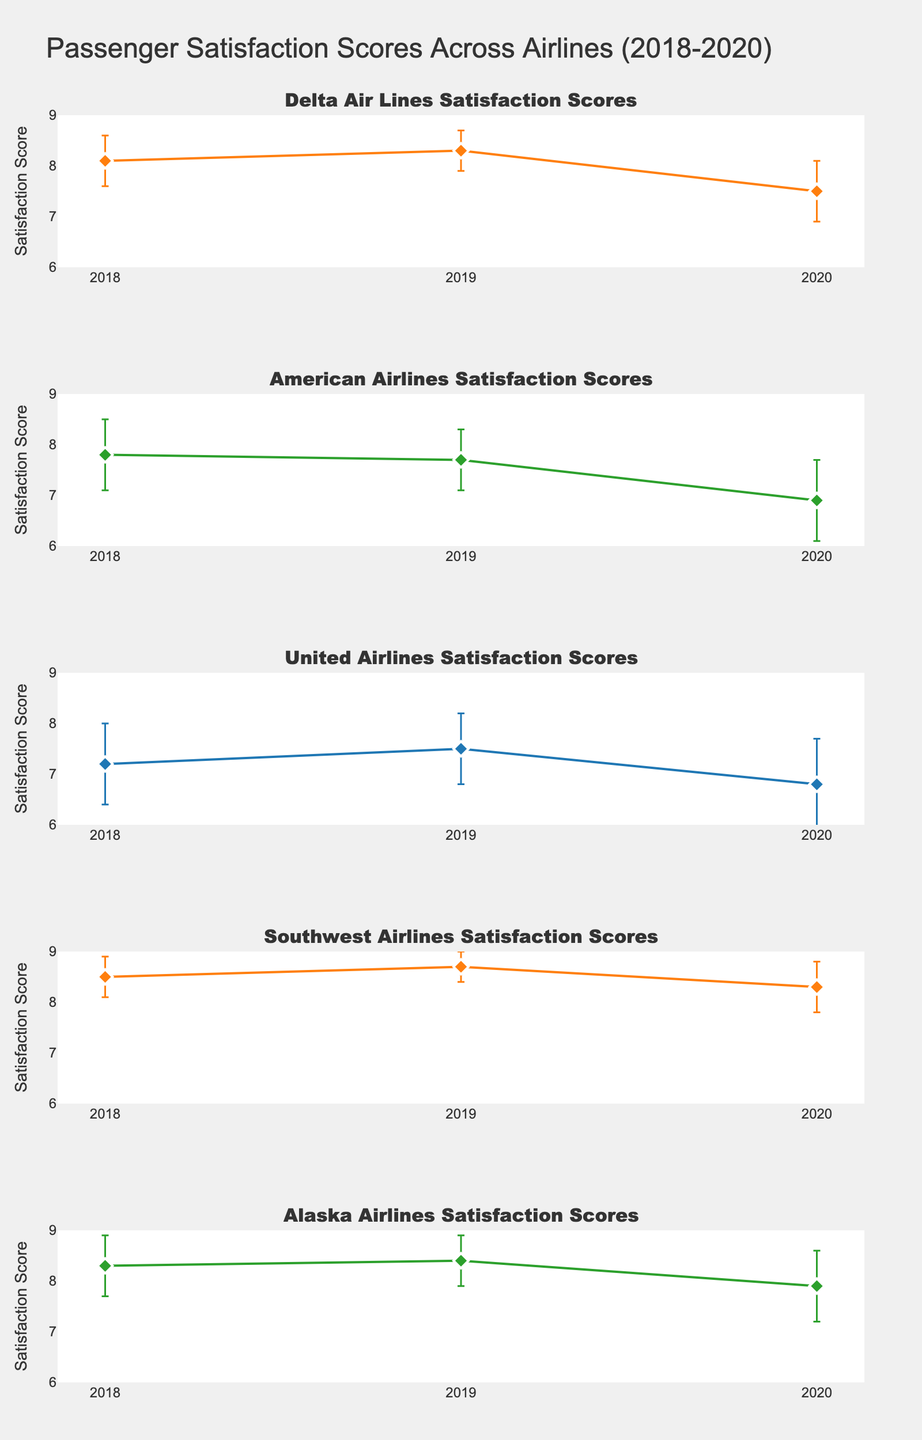How has Delta Air Lines' satisfaction score changed from 2018 to 2020? To answer this, we look at Delta Air Lines' satisfaction scores for 2018 and 2020. In 2018, it was 8.1, and in 2020, it was 7.5. We see a decrease in satisfaction score.
Answer: It decreased by 0.6 What was Southwest Airlines' highest average satisfaction score during the period 2018-2020? Checking the values for Southwest Airlines, the scores are 8.5 in 2018, 8.7 in 2019, and 8.3 in 2020. The highest score is 8.7 in 2019.
Answer: 8.7 in 2019 Which airline had the lowest average satisfaction score in 2020? For 2020, Delta Air Lines had 7.5, American Airlines had 6.9, United Airlines had 6.8, Southwest Airlines had 8.3, and Alaska Airlines had 7.9. The lowest score is 6.8 by United Airlines.
Answer: United Airlines How much did American Airlines' satisfaction score change between 2019 and 2020, considering the standard deviations? In 2019, American Airlines had a score of 7.7 with a standard deviation of 0.6. In 2020, it had a score of 6.9 with a standard deviation of 0.8. The change is 7.7 - 6.9 = 0.8. Considering standard deviations, the scores' ranges are mostly non-overlapping, indicating a notable change.
Answer: Changed by 0.8 Compare the average satisfaction scores of Alaska Airlines and United Airlines in 2019. Which was higher and by how much? Alaska Airlines had an average score of 8.4 in 2019, while United Airlines had 7.5. To compare, 8.4 - 7.5 = 0.9, so Alaska Airlines had a higher score by 0.9.
Answer: Alaska Airlines by 0.9 Which airline experienced the greatest drop in average satisfaction from 2018 to 2020? Look at the satisfaction scores from 2018 to 2020: Delta Air Lines dropped from 8.1 to 7.5 (-0.6), American Airlines from 7.8 to 6.9 (-0.9), United Airlines from 7.2 to 6.8 (-0.4), Southwest Airlines from 8.5 to 8.3 (-0.2), and Alaska Airlines from 8.3 to 7.9 (-0.4). The greatest drop is by American Airlines at -0.9.
Answer: American Airlines Which airline had the least variation in satisfaction scores over the three years? The least variation means looking for the smallest standard deviations. Calculate ranges for each: Delta Air Lines (0.5, 0.4, 0.6), American Airlines (0.7, 0.6, 0.8), United Airlines (0.8, 0.7, 0.9), Southwest Airlines (0.4, 0.3, 0.5), and Alaska Airlines (0.6, 0.5, 0.7). Southwest Airlines consistently has the smallest deviations.
Answer: Southwest Airlines For which years did American Airlines' satisfaction scores have overlapping error bars? Consider the standard deviations: 2018 (7.8 ± 0.7), 2019 (7.7 ± 0.6), and 2020 (6.9 ± 0.8). The error bars of 2018 and 2019 overlap since 7.8 - 0.7 to 7.8 + 0.7 (7.1 to 8.5) and 7.7 - 0.6 to 7.7 + 0.6 (7.1 to 8.3), but not 2020 which ranges 6.1 to 7.7 overlapping only upto 7.7.
Answer: 2018 and 2019 